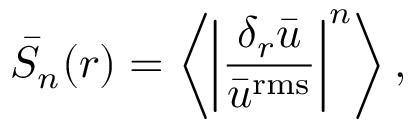<formula> <loc_0><loc_0><loc_500><loc_500>\bar { S } _ { n } ( r ) = \left \langle \left | \frac { \delta _ { r } \bar { u } } { \bar { u } ^ { r m s } } \right | ^ { n } \right \rangle ,</formula> 